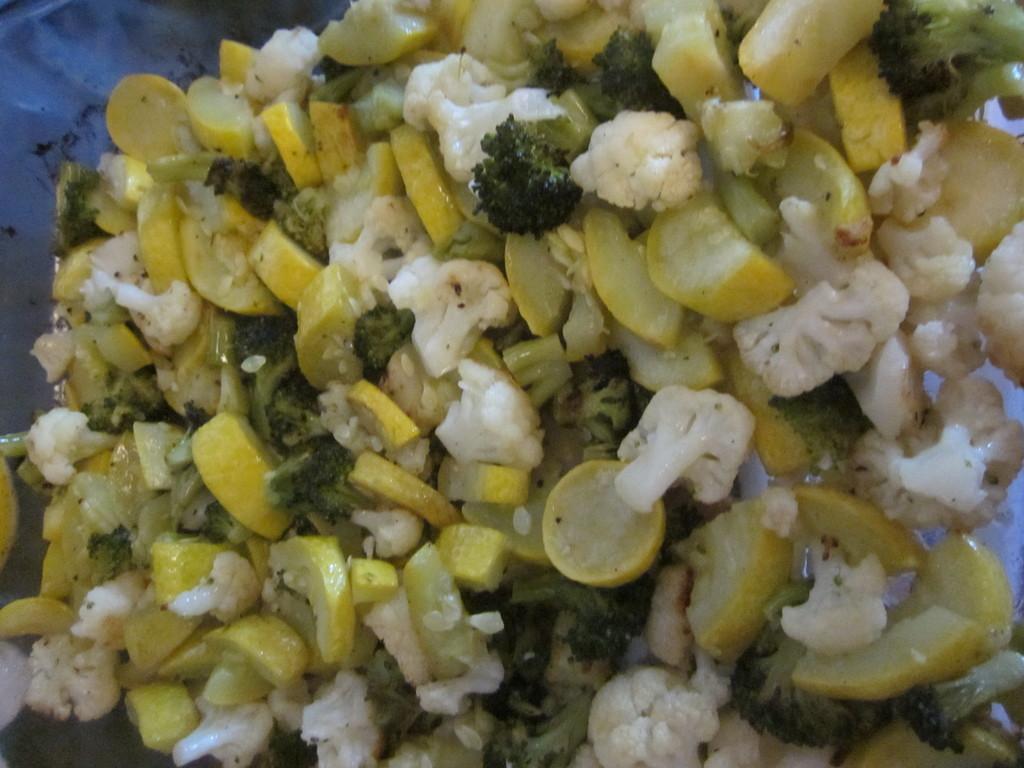How would you summarize this image in a sentence or two? In this image, we can see some food. 